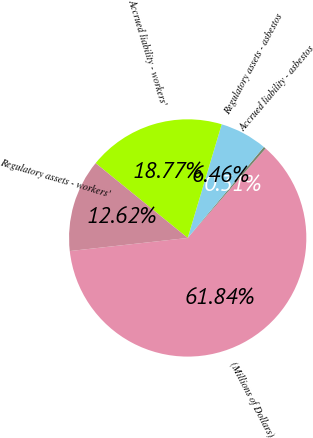Convert chart. <chart><loc_0><loc_0><loc_500><loc_500><pie_chart><fcel>(Millions of Dollars)<fcel>Accrued liability - asbestos<fcel>Regulatory assets - asbestos<fcel>Accrued liability - workers'<fcel>Regulatory assets - workers'<nl><fcel>61.85%<fcel>0.31%<fcel>6.46%<fcel>18.77%<fcel>12.62%<nl></chart> 